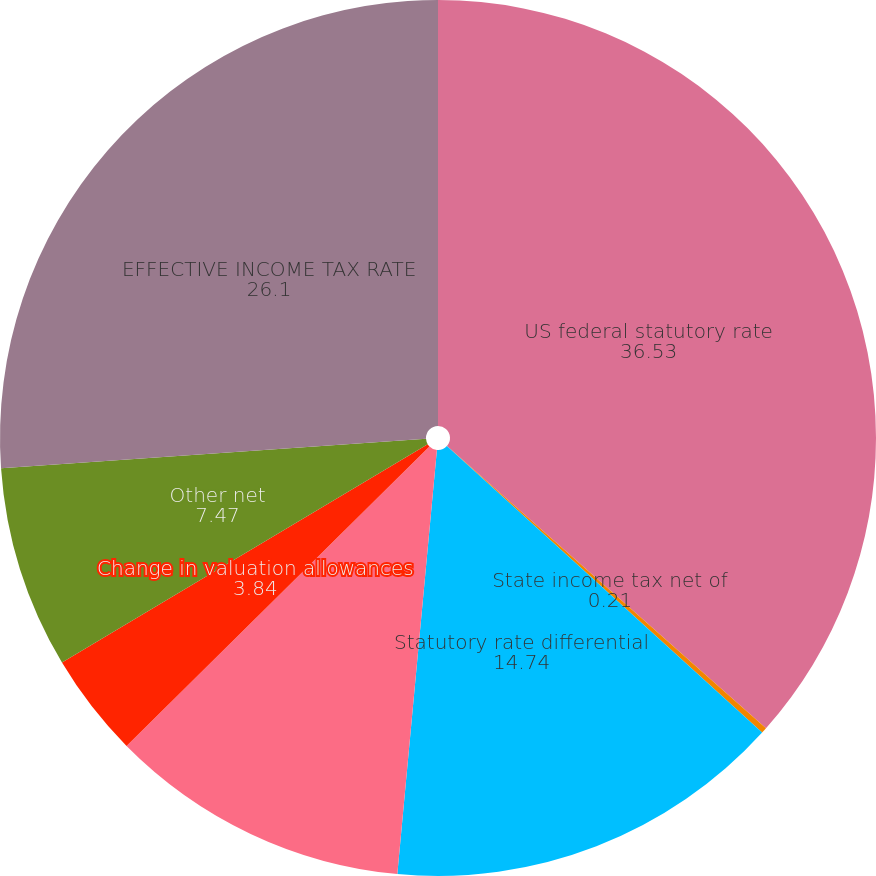<chart> <loc_0><loc_0><loc_500><loc_500><pie_chart><fcel>US federal statutory rate<fcel>State income tax net of<fcel>Statutory rate differential<fcel>Adjustments to reserves and<fcel>Change in valuation allowances<fcel>Other net<fcel>EFFECTIVE INCOME TAX RATE<nl><fcel>36.53%<fcel>0.21%<fcel>14.74%<fcel>11.11%<fcel>3.84%<fcel>7.47%<fcel>26.1%<nl></chart> 